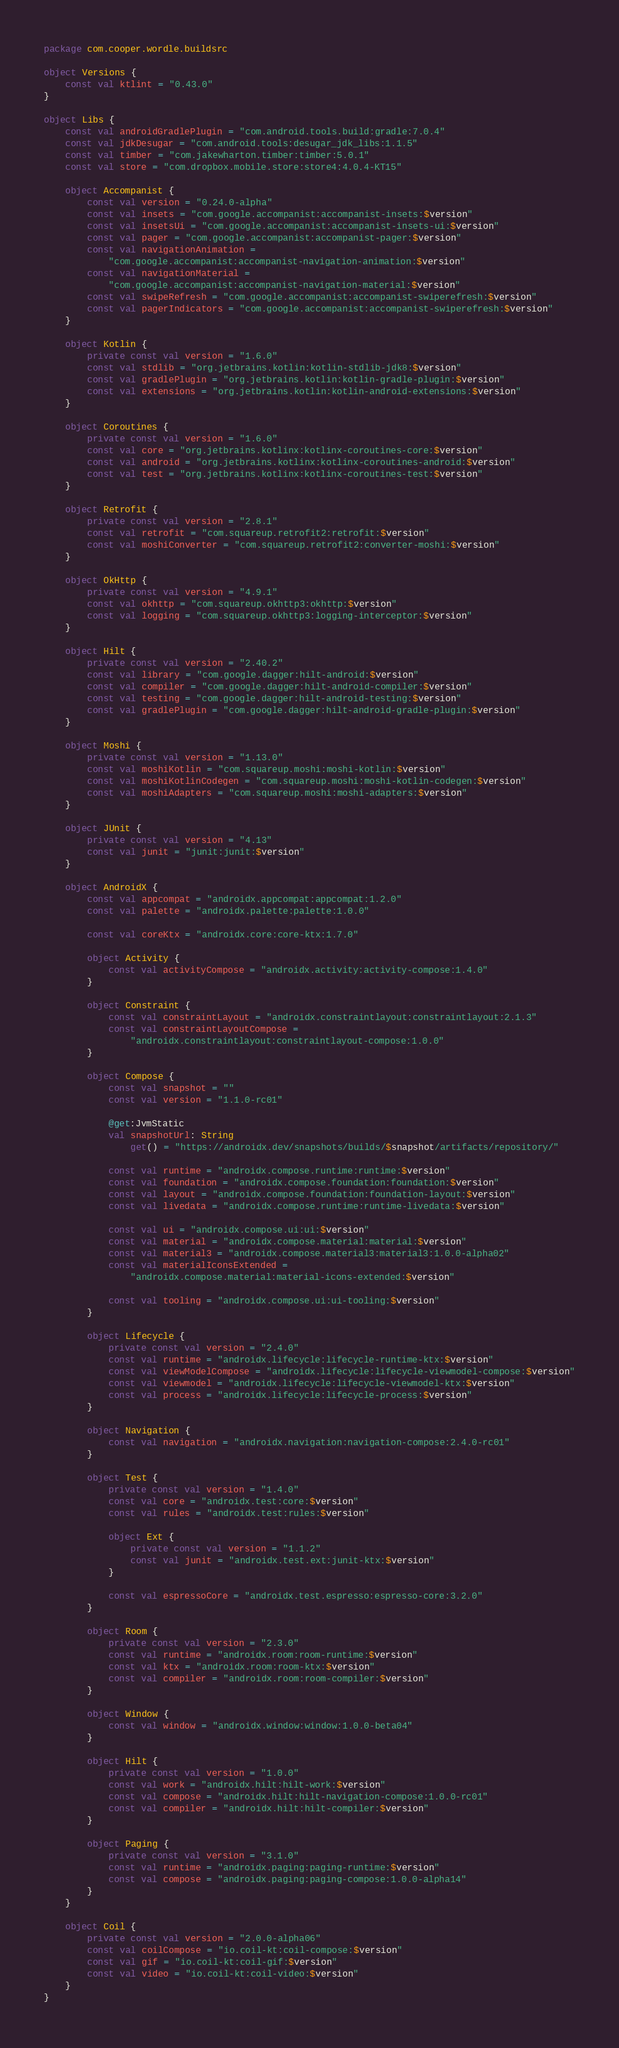Convert code to text. <code><loc_0><loc_0><loc_500><loc_500><_Kotlin_>package com.cooper.wordle.buildsrc

object Versions {
    const val ktlint = "0.43.0"
}

object Libs {
    const val androidGradlePlugin = "com.android.tools.build:gradle:7.0.4"
    const val jdkDesugar = "com.android.tools:desugar_jdk_libs:1.1.5"
    const val timber = "com.jakewharton.timber:timber:5.0.1"
    const val store = "com.dropbox.mobile.store:store4:4.0.4-KT15"

    object Accompanist {
        const val version = "0.24.0-alpha"
        const val insets = "com.google.accompanist:accompanist-insets:$version"
        const val insetsUi = "com.google.accompanist:accompanist-insets-ui:$version"
        const val pager = "com.google.accompanist:accompanist-pager:$version"
        const val navigationAnimation =
            "com.google.accompanist:accompanist-navigation-animation:$version"
        const val navigationMaterial =
            "com.google.accompanist:accompanist-navigation-material:$version"
        const val swipeRefresh = "com.google.accompanist:accompanist-swiperefresh:$version"
        const val pagerIndicators = "com.google.accompanist:accompanist-swiperefresh:$version"
    }

    object Kotlin {
        private const val version = "1.6.0"
        const val stdlib = "org.jetbrains.kotlin:kotlin-stdlib-jdk8:$version"
        const val gradlePlugin = "org.jetbrains.kotlin:kotlin-gradle-plugin:$version"
        const val extensions = "org.jetbrains.kotlin:kotlin-android-extensions:$version"
    }

    object Coroutines {
        private const val version = "1.6.0"
        const val core = "org.jetbrains.kotlinx:kotlinx-coroutines-core:$version"
        const val android = "org.jetbrains.kotlinx:kotlinx-coroutines-android:$version"
        const val test = "org.jetbrains.kotlinx:kotlinx-coroutines-test:$version"
    }

    object Retrofit {
        private const val version = "2.8.1"
        const val retrofit = "com.squareup.retrofit2:retrofit:$version"
        const val moshiConverter = "com.squareup.retrofit2:converter-moshi:$version"
    }

    object OkHttp {
        private const val version = "4.9.1"
        const val okhttp = "com.squareup.okhttp3:okhttp:$version"
        const val logging = "com.squareup.okhttp3:logging-interceptor:$version"
    }

    object Hilt {
        private const val version = "2.40.2"
        const val library = "com.google.dagger:hilt-android:$version"
        const val compiler = "com.google.dagger:hilt-android-compiler:$version"
        const val testing = "com.google.dagger:hilt-android-testing:$version"
        const val gradlePlugin = "com.google.dagger:hilt-android-gradle-plugin:$version"
    }

    object Moshi {
        private const val version = "1.13.0"
        const val moshiKotlin = "com.squareup.moshi:moshi-kotlin:$version"
        const val moshiKotlinCodegen = "com.squareup.moshi:moshi-kotlin-codegen:$version"
        const val moshiAdapters = "com.squareup.moshi:moshi-adapters:$version"
    }

    object JUnit {
        private const val version = "4.13"
        const val junit = "junit:junit:$version"
    }

    object AndroidX {
        const val appcompat = "androidx.appcompat:appcompat:1.2.0"
        const val palette = "androidx.palette:palette:1.0.0"

        const val coreKtx = "androidx.core:core-ktx:1.7.0"

        object Activity {
            const val activityCompose = "androidx.activity:activity-compose:1.4.0"
        }

        object Constraint {
            const val constraintLayout = "androidx.constraintlayout:constraintlayout:2.1.3"
            const val constraintLayoutCompose =
                "androidx.constraintlayout:constraintlayout-compose:1.0.0"
        }

        object Compose {
            const val snapshot = ""
            const val version = "1.1.0-rc01"

            @get:JvmStatic
            val snapshotUrl: String
                get() = "https://androidx.dev/snapshots/builds/$snapshot/artifacts/repository/"

            const val runtime = "androidx.compose.runtime:runtime:$version"
            const val foundation = "androidx.compose.foundation:foundation:$version"
            const val layout = "androidx.compose.foundation:foundation-layout:$version"
            const val livedata = "androidx.compose.runtime:runtime-livedata:$version"

            const val ui = "androidx.compose.ui:ui:$version"
            const val material = "androidx.compose.material:material:$version"
            const val material3 = "androidx.compose.material3:material3:1.0.0-alpha02"
            const val materialIconsExtended =
                "androidx.compose.material:material-icons-extended:$version"

            const val tooling = "androidx.compose.ui:ui-tooling:$version"
        }

        object Lifecycle {
            private const val version = "2.4.0"
            const val runtime = "androidx.lifecycle:lifecycle-runtime-ktx:$version"
            const val viewModelCompose = "androidx.lifecycle:lifecycle-viewmodel-compose:$version"
            const val viewmodel = "androidx.lifecycle:lifecycle-viewmodel-ktx:$version"
            const val process = "androidx.lifecycle:lifecycle-process:$version"
        }

        object Navigation {
            const val navigation = "androidx.navigation:navigation-compose:2.4.0-rc01"
        }

        object Test {
            private const val version = "1.4.0"
            const val core = "androidx.test:core:$version"
            const val rules = "androidx.test:rules:$version"

            object Ext {
                private const val version = "1.1.2"
                const val junit = "androidx.test.ext:junit-ktx:$version"
            }

            const val espressoCore = "androidx.test.espresso:espresso-core:3.2.0"
        }

        object Room {
            private const val version = "2.3.0"
            const val runtime = "androidx.room:room-runtime:$version"
            const val ktx = "androidx.room:room-ktx:$version"
            const val compiler = "androidx.room:room-compiler:$version"
        }

        object Window {
            const val window = "androidx.window:window:1.0.0-beta04"
        }

        object Hilt {
            private const val version = "1.0.0"
            const val work = "androidx.hilt:hilt-work:$version"
            const val compose = "androidx.hilt:hilt-navigation-compose:1.0.0-rc01"
            const val compiler = "androidx.hilt:hilt-compiler:$version"
        }

        object Paging {
            private const val version = "3.1.0"
            const val runtime = "androidx.paging:paging-runtime:$version"
            const val compose = "androidx.paging:paging-compose:1.0.0-alpha14"
        }
    }

    object Coil {
        private const val version = "2.0.0-alpha06"
        const val coilCompose = "io.coil-kt:coil-compose:$version"
        const val gif = "io.coil-kt:coil-gif:$version"
        const val video = "io.coil-kt:coil-video:$version"
    }
}
</code> 